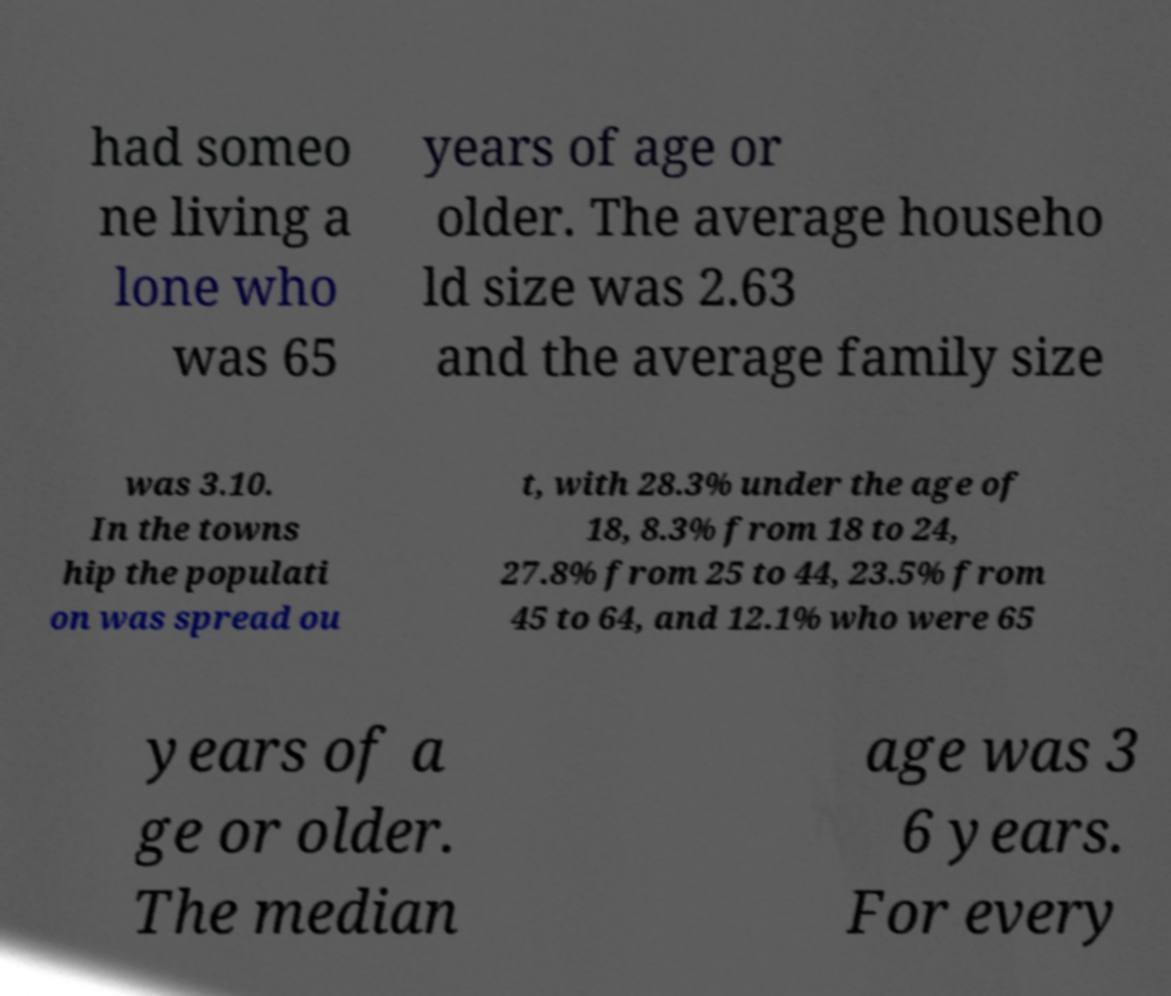There's text embedded in this image that I need extracted. Can you transcribe it verbatim? had someo ne living a lone who was 65 years of age or older. The average househo ld size was 2.63 and the average family size was 3.10. In the towns hip the populati on was spread ou t, with 28.3% under the age of 18, 8.3% from 18 to 24, 27.8% from 25 to 44, 23.5% from 45 to 64, and 12.1% who were 65 years of a ge or older. The median age was 3 6 years. For every 